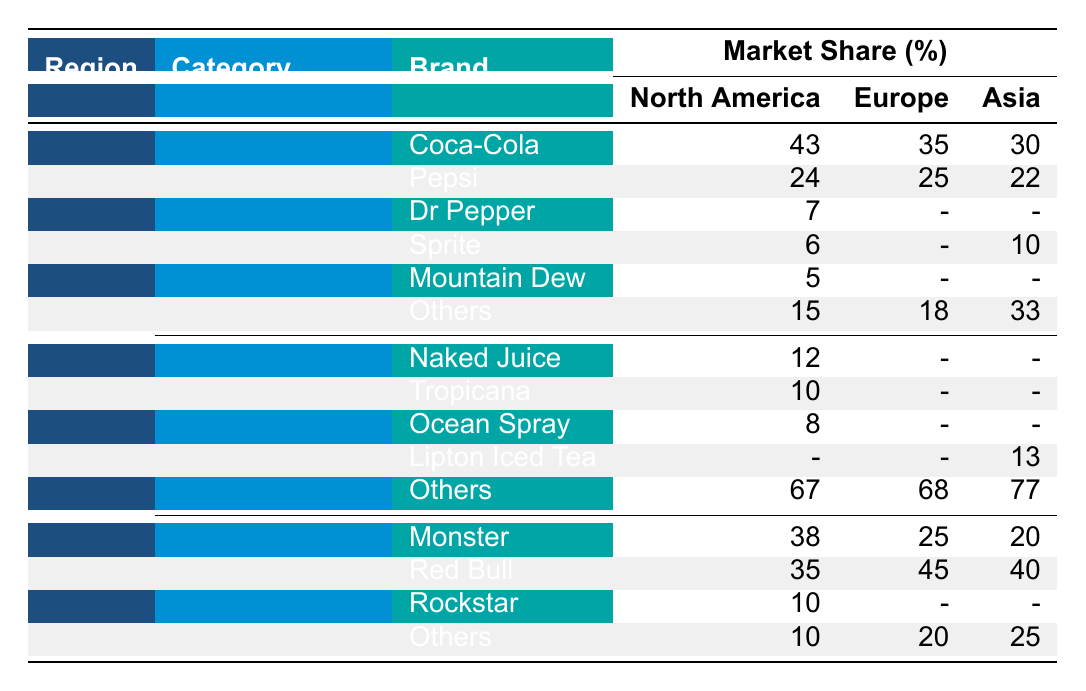What is the market share of Coca-Cola in North America for carbonated drinks? The table shows that Coca-Cola holds a 43% market share in North America under the carbonated drinks category.
Answer: 43% Which brand has the highest market share in energy drinks in Europe? According to the table, Red Bull has the highest market share in energy drinks in Europe, with a 45% share.
Answer: Red Bull What is the total market share of "Others" in the non-carbonated drinks category across all regions? By referring to the table, the market shares for "Others" in non-carbonated drinks are 67% in North America, 68% in Europe, and 77% in Asia. Adding them gives 67 + 68 + 77 = 212%.
Answer: 212% Which region has the lowest market share of energy drinks and what is it? The table indicates that Asia has the lowest market share for energy drinks at 20%, compared to North America (38%) and Europe (25%).
Answer: Asia, 20% For which brand in non-carbonated drinks does North America have the highest share, and what is that share? The North America non-carbonated drinks market shows "Others" with the highest share at 67%, while the next highest share belongs to Naked Juice at 12%.
Answer: "Others", 67% Is Pepsi ranked higher than Dr Pepper in the carbonated drinks category in North America? Yes, the table lists Pepsi with a market share of 24%, which is higher than Dr Pepper's 7% share in the same category.
Answer: Yes What is the average market share for Monster across all regions? From the table, Monster has shares of 38% in North America, 25% in Europe, and 20% in Asia. To find the average, calculate (38 + 25 + 20) / 3 = 27.67.
Answer: 27.67% What percentage of the carbonated drink market do "Others" hold in Asia? The table shows that "Others" in the carbonated drinks category in Asia holds a 33% market share.
Answer: 33% Is the total market share of Coca-Cola in carbonated drinks across all regions more than 100%? Coca-Cola's shares are 43% (North America), 35% (Europe), and 30% (Asia). Adding these yields 43 + 35 + 30 = 108%, which exceeds 100%.
Answer: Yes Which category has the largest market share of "Others" across all regions and what is that percentage? For carbonated drinks, "Others" holds 15% (North America), 18% (Europe), and 33% (Asia), totaling 66%. In non-carbonated drinks, "Others" contains 67% (North America), 68% (Europe), and 77% (Asia), totaling 212%. Hence, non-carbonated drinks have the largest share.
Answer: Non-carbonated drinks, 212% 